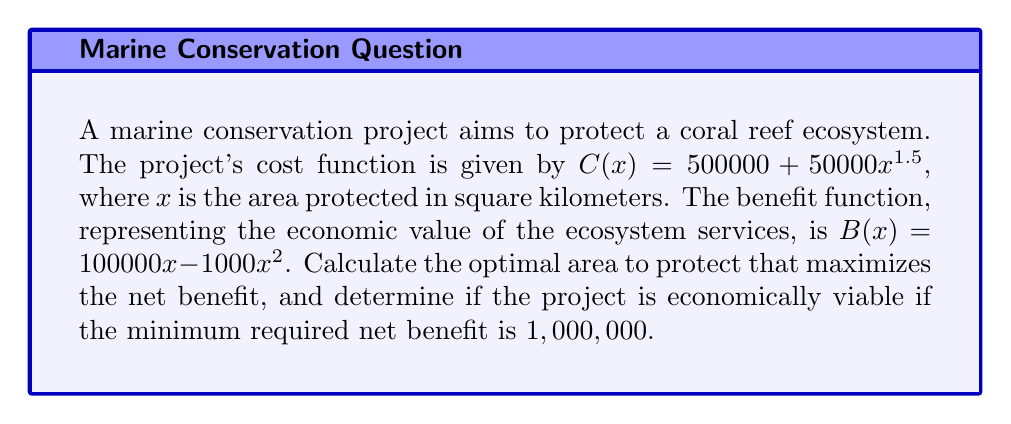Give your solution to this math problem. 1) The net benefit function is given by $NB(x) = B(x) - C(x)$:
   $$NB(x) = (100000x - 1000x^2) - (500000 + 50000x^{1.5})$$

2) To find the maximum net benefit, we need to find where the derivative of $NB(x)$ equals zero:
   $$\frac{d}{dx}NB(x) = 100000 - 2000x - 75000x^{0.5} = 0$$

3) This equation is nonlinear and can be solved numerically. Using a numerical method (e.g., Newton-Raphson), we find that $x \approx 33.47$ km².

4) To verify this is a maximum, we can check the second derivative is negative at this point:
   $$\frac{d^2}{dx^2}NB(x) = -2000 - 37500x^{-0.5} < 0$$ for $x > 0$

5) Calculating the net benefit at $x = 33.47$:
   $$NB(33.47) \approx 1,118,350$$

6) Since $1,118,350 > 1,000,000$, the project is economically viable.
Answer: Optimal area: 33.47 km²; Economically viable: Yes 